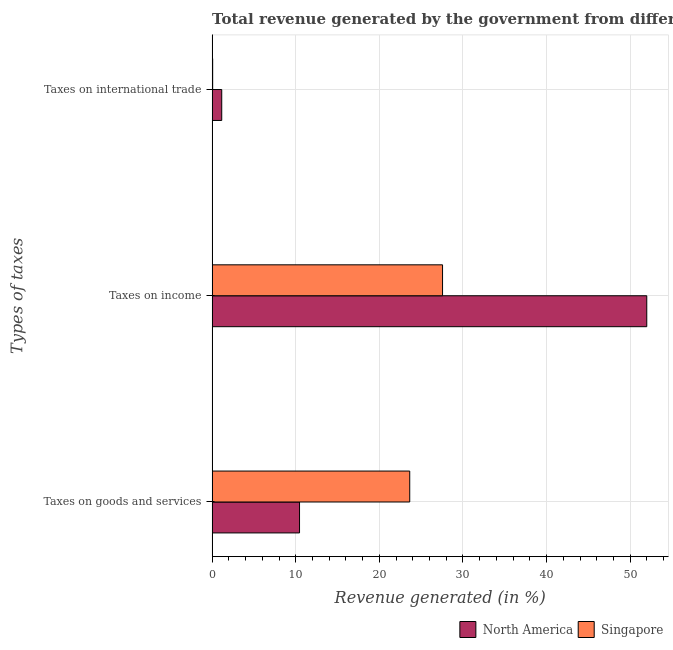How many different coloured bars are there?
Keep it short and to the point. 2. What is the label of the 3rd group of bars from the top?
Ensure brevity in your answer.  Taxes on goods and services. What is the percentage of revenue generated by tax on international trade in Singapore?
Your response must be concise. 0.07. Across all countries, what is the maximum percentage of revenue generated by taxes on goods and services?
Ensure brevity in your answer.  23.63. Across all countries, what is the minimum percentage of revenue generated by tax on international trade?
Make the answer very short. 0.07. In which country was the percentage of revenue generated by taxes on income maximum?
Your answer should be very brief. North America. In which country was the percentage of revenue generated by taxes on income minimum?
Give a very brief answer. Singapore. What is the total percentage of revenue generated by taxes on income in the graph?
Keep it short and to the point. 79.54. What is the difference between the percentage of revenue generated by taxes on goods and services in North America and that in Singapore?
Your response must be concise. -13.18. What is the difference between the percentage of revenue generated by taxes on income in Singapore and the percentage of revenue generated by taxes on goods and services in North America?
Make the answer very short. 17.1. What is the average percentage of revenue generated by taxes on income per country?
Your response must be concise. 39.77. What is the difference between the percentage of revenue generated by taxes on goods and services and percentage of revenue generated by tax on international trade in North America?
Provide a succinct answer. 9.3. What is the ratio of the percentage of revenue generated by taxes on income in Singapore to that in North America?
Your answer should be compact. 0.53. What is the difference between the highest and the second highest percentage of revenue generated by taxes on goods and services?
Your response must be concise. 13.18. What is the difference between the highest and the lowest percentage of revenue generated by tax on international trade?
Provide a succinct answer. 1.08. What does the 1st bar from the top in Taxes on income represents?
Ensure brevity in your answer.  Singapore. What does the 2nd bar from the bottom in Taxes on international trade represents?
Make the answer very short. Singapore. Is it the case that in every country, the sum of the percentage of revenue generated by taxes on goods and services and percentage of revenue generated by taxes on income is greater than the percentage of revenue generated by tax on international trade?
Ensure brevity in your answer.  Yes. How many bars are there?
Give a very brief answer. 6. How many countries are there in the graph?
Offer a very short reply. 2. What is the difference between two consecutive major ticks on the X-axis?
Make the answer very short. 10. Are the values on the major ticks of X-axis written in scientific E-notation?
Ensure brevity in your answer.  No. Does the graph contain grids?
Provide a succinct answer. Yes. Where does the legend appear in the graph?
Provide a succinct answer. Bottom right. How many legend labels are there?
Your response must be concise. 2. How are the legend labels stacked?
Provide a short and direct response. Horizontal. What is the title of the graph?
Your answer should be compact. Total revenue generated by the government from different taxes in 2004. What is the label or title of the X-axis?
Provide a short and direct response. Revenue generated (in %). What is the label or title of the Y-axis?
Your response must be concise. Types of taxes. What is the Revenue generated (in %) of North America in Taxes on goods and services?
Provide a succinct answer. 10.45. What is the Revenue generated (in %) in Singapore in Taxes on goods and services?
Your response must be concise. 23.63. What is the Revenue generated (in %) of North America in Taxes on income?
Your response must be concise. 51.98. What is the Revenue generated (in %) in Singapore in Taxes on income?
Your response must be concise. 27.56. What is the Revenue generated (in %) in North America in Taxes on international trade?
Your answer should be compact. 1.15. What is the Revenue generated (in %) of Singapore in Taxes on international trade?
Your response must be concise. 0.07. Across all Types of taxes, what is the maximum Revenue generated (in %) of North America?
Offer a terse response. 51.98. Across all Types of taxes, what is the maximum Revenue generated (in %) of Singapore?
Provide a succinct answer. 27.56. Across all Types of taxes, what is the minimum Revenue generated (in %) of North America?
Offer a very short reply. 1.15. Across all Types of taxes, what is the minimum Revenue generated (in %) of Singapore?
Ensure brevity in your answer.  0.07. What is the total Revenue generated (in %) in North America in the graph?
Keep it short and to the point. 63.58. What is the total Revenue generated (in %) of Singapore in the graph?
Make the answer very short. 51.25. What is the difference between the Revenue generated (in %) of North America in Taxes on goods and services and that in Taxes on income?
Provide a short and direct response. -41.53. What is the difference between the Revenue generated (in %) in Singapore in Taxes on goods and services and that in Taxes on income?
Keep it short and to the point. -3.92. What is the difference between the Revenue generated (in %) in North America in Taxes on goods and services and that in Taxes on international trade?
Your answer should be very brief. 9.3. What is the difference between the Revenue generated (in %) in Singapore in Taxes on goods and services and that in Taxes on international trade?
Provide a succinct answer. 23.57. What is the difference between the Revenue generated (in %) in North America in Taxes on income and that in Taxes on international trade?
Provide a short and direct response. 50.83. What is the difference between the Revenue generated (in %) in Singapore in Taxes on income and that in Taxes on international trade?
Provide a short and direct response. 27.49. What is the difference between the Revenue generated (in %) in North America in Taxes on goods and services and the Revenue generated (in %) in Singapore in Taxes on income?
Keep it short and to the point. -17.1. What is the difference between the Revenue generated (in %) of North America in Taxes on goods and services and the Revenue generated (in %) of Singapore in Taxes on international trade?
Provide a short and direct response. 10.39. What is the difference between the Revenue generated (in %) of North America in Taxes on income and the Revenue generated (in %) of Singapore in Taxes on international trade?
Your answer should be compact. 51.91. What is the average Revenue generated (in %) of North America per Types of taxes?
Offer a terse response. 21.19. What is the average Revenue generated (in %) of Singapore per Types of taxes?
Your response must be concise. 17.08. What is the difference between the Revenue generated (in %) of North America and Revenue generated (in %) of Singapore in Taxes on goods and services?
Your answer should be very brief. -13.18. What is the difference between the Revenue generated (in %) in North America and Revenue generated (in %) in Singapore in Taxes on income?
Offer a terse response. 24.42. What is the difference between the Revenue generated (in %) of North America and Revenue generated (in %) of Singapore in Taxes on international trade?
Keep it short and to the point. 1.08. What is the ratio of the Revenue generated (in %) in North America in Taxes on goods and services to that in Taxes on income?
Provide a short and direct response. 0.2. What is the ratio of the Revenue generated (in %) in Singapore in Taxes on goods and services to that in Taxes on income?
Your answer should be very brief. 0.86. What is the ratio of the Revenue generated (in %) in North America in Taxes on goods and services to that in Taxes on international trade?
Offer a very short reply. 9.09. What is the ratio of the Revenue generated (in %) of Singapore in Taxes on goods and services to that in Taxes on international trade?
Offer a very short reply. 359.58. What is the ratio of the Revenue generated (in %) of North America in Taxes on income to that in Taxes on international trade?
Your answer should be very brief. 45.19. What is the ratio of the Revenue generated (in %) of Singapore in Taxes on income to that in Taxes on international trade?
Your answer should be compact. 419.29. What is the difference between the highest and the second highest Revenue generated (in %) in North America?
Provide a short and direct response. 41.53. What is the difference between the highest and the second highest Revenue generated (in %) of Singapore?
Ensure brevity in your answer.  3.92. What is the difference between the highest and the lowest Revenue generated (in %) in North America?
Your answer should be very brief. 50.83. What is the difference between the highest and the lowest Revenue generated (in %) in Singapore?
Keep it short and to the point. 27.49. 